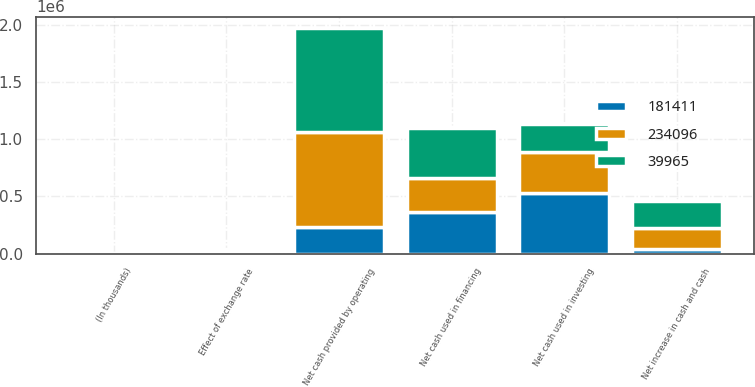<chart> <loc_0><loc_0><loc_500><loc_500><stacked_bar_chart><ecel><fcel>(In thousands)<fcel>Net cash provided by operating<fcel>Net cash used in investing<fcel>Net cash used in financing<fcel>Effect of exchange rate<fcel>Net increase in cash and cash<nl><fcel>39965<fcel>2013<fcel>913188<fcel>241447<fcel>428510<fcel>9135<fcel>234096<nl><fcel>181411<fcel>2012<fcel>234096<fcel>528891<fcel>364103<fcel>8658<fcel>39965<nl><fcel>234096<fcel>2011<fcel>823166<fcel>359510<fcel>300155<fcel>17910<fcel>181411<nl></chart> 